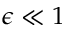<formula> <loc_0><loc_0><loc_500><loc_500>\epsilon \ll 1</formula> 